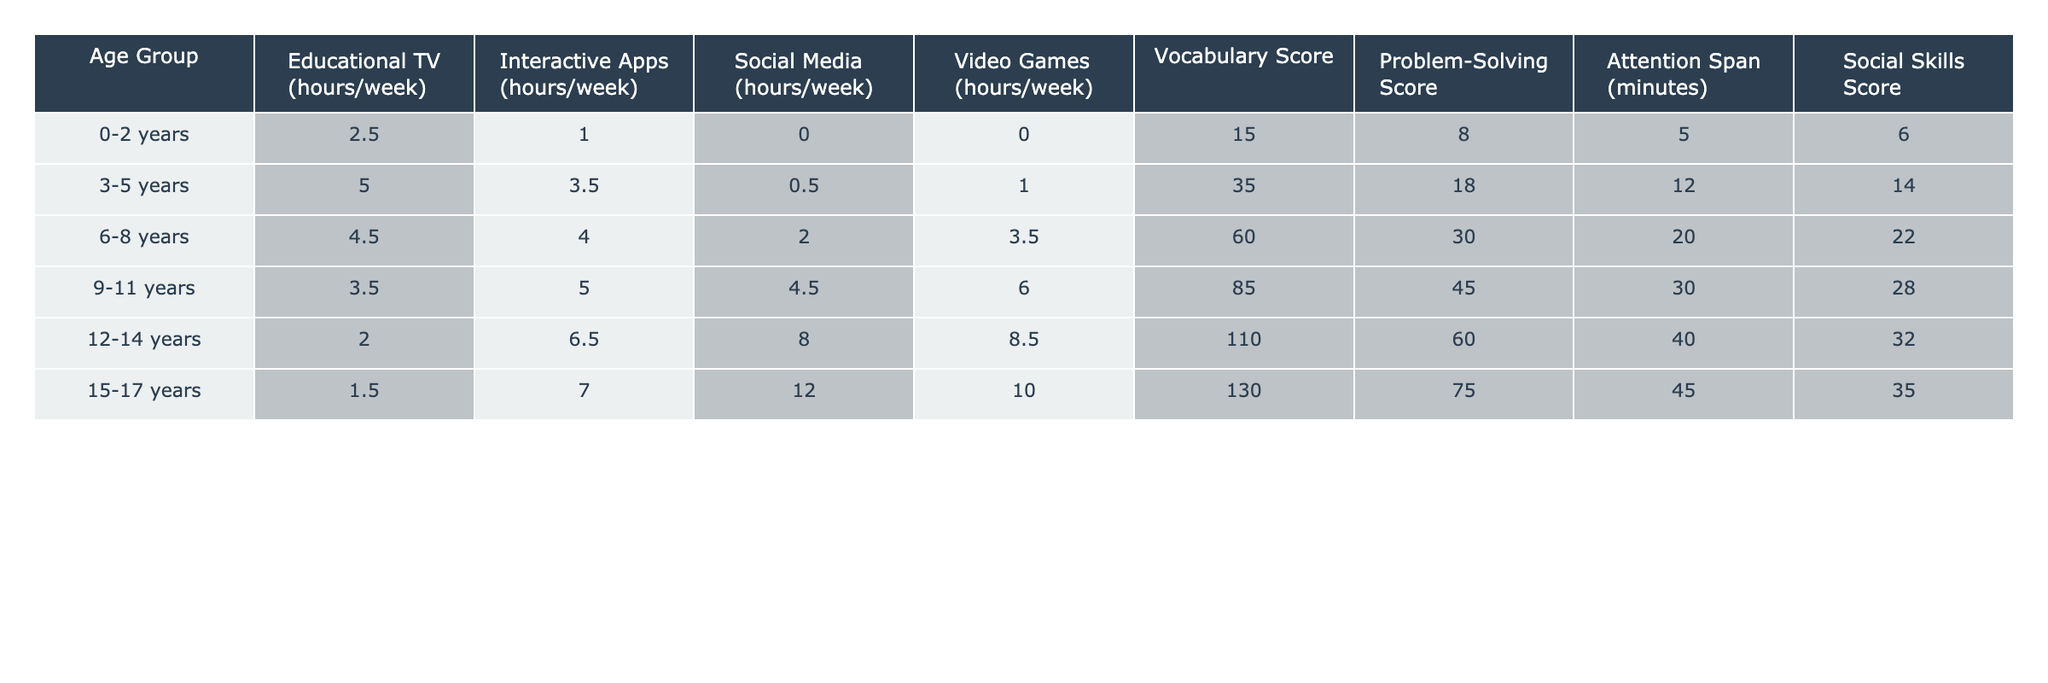What is the Vocabulary Score for the 3-5 years age group? The Vocabulary Score for the 3-5 years age group is directly provided in the table. Referring to the row for this age group, the score is 35.
Answer: 35 What is the average weekly screen time from Video Games for children aged 6-8? To find the average weekly screen time for Video Games in this age group, we consider the value directly from the table, which is 3.5 hours.
Answer: 3.5 Is the Problem-Solving Score for 12-14 years higher than that for 9-11 years? From the table, the Problem-Solving Score for 12-14 years is 60, while for 9-11 years it is 45. Since 60 is greater than 45, the statement is true.
Answer: Yes What is the total Screen Time (sum of all types) for the 0-2 years age group? For the 0-2 years age group, we sum the hours for all media content: Educational TV (2.5) + Interactive Apps (1.0) + Social Media (0.0) + Video Games (0.0) = 3.5 hours total.
Answer: 3.5 How does the Attention Span change from 3-5 years to 6-8 years? The Attention Span for 3-5 years is 12 minutes and for 6-8 years is 20 minutes. The change can be found by calculating the difference: 20 - 12 = 8. This indicates an increase.
Answer: Increases by 8 minutes What is the total screen time from Interactive Apps for the 15-17 years age group compared to the 3-5 years age group? From the table, for 15-17 years, Interactive Apps usage is 7.0 hours, and for 3-5 years, it is 3.5 hours. The total difference is 7.0 - 3.5 = 3.5, indicating that 15-17 year olds spend more time.
Answer: 3.5 hours more What is the highest Vocabulary Score and which age group corresponds to it? Looking at the table, the highest Vocabulary Score is 130, which corresponds to the 15-17 years age group, as we can see this from the respective row.
Answer: 130; 15-17 years For which age group does Vocabulary Score increase the most compared to the previous age group? By comparing the Vocabulary Scores of each age group: 35 (3-5) to 60 (6-8) is an increase of 25. Similarly, for 6-8 to 9-11, it increases by 25 as well. The increase from 9-11 (85) to 12-14 (110) is also 25, and the last comparison is 20 to 130 which is a 20 point increase. Hence, the maximum increase occurs between 3-5 years to 6-8 years.
Answer: 25-point increase; from 3-5 to 6-8 years Is it true that as the age increases, the time spent on Social Media also increases? From the data for Social Media: 0.0 (0-2), 0.5 (3-5), 2.0 (6-8), 4.5 (9-11), 8.0 (12-14), and 12.0 (15-17). The values are indeed increasing with age, indicating a true correlation.
Answer: Yes 